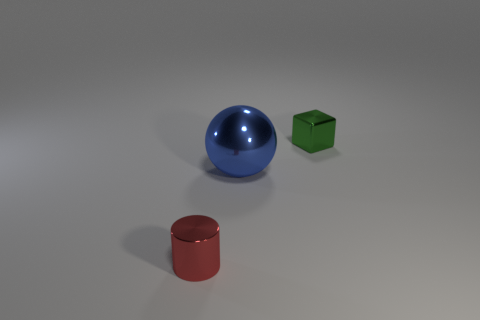What is the sphere made of?
Ensure brevity in your answer.  Metal. Is the number of big spheres greater than the number of small brown rubber blocks?
Make the answer very short. Yes. Is there any other thing that is the same shape as the small red thing?
Ensure brevity in your answer.  No. Is the number of red objects that are in front of the small red metallic object less than the number of small metallic things to the right of the large metal ball?
Keep it short and to the point. Yes. There is a metal thing that is behind the large thing; what is its shape?
Provide a short and direct response. Cube. What number of other things are made of the same material as the red cylinder?
Your response must be concise. 2. There is another large thing that is the same material as the green thing; what shape is it?
Offer a very short reply. Sphere. Are there more metal objects that are behind the tiny cylinder than blue spheres in front of the large ball?
Your response must be concise. Yes. What number of things are either big metallic things or large gray metallic blocks?
Keep it short and to the point. 1. How many other things are there of the same color as the big object?
Give a very brief answer. 0. 